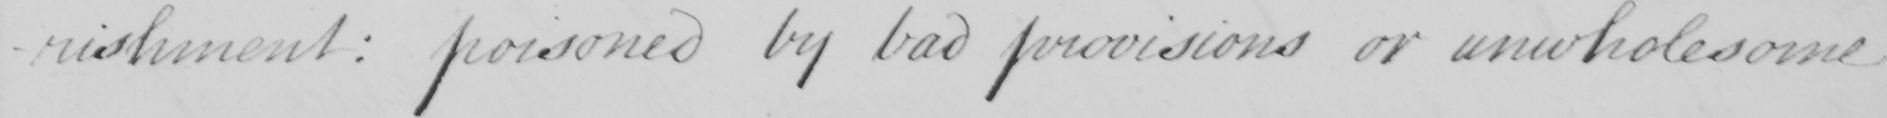What does this handwritten line say? -rishment  :  poisoned by bad provisions or unwholesome 